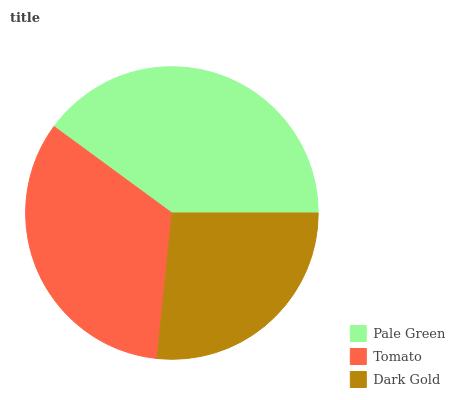Is Dark Gold the minimum?
Answer yes or no. Yes. Is Pale Green the maximum?
Answer yes or no. Yes. Is Tomato the minimum?
Answer yes or no. No. Is Tomato the maximum?
Answer yes or no. No. Is Pale Green greater than Tomato?
Answer yes or no. Yes. Is Tomato less than Pale Green?
Answer yes or no. Yes. Is Tomato greater than Pale Green?
Answer yes or no. No. Is Pale Green less than Tomato?
Answer yes or no. No. Is Tomato the high median?
Answer yes or no. Yes. Is Tomato the low median?
Answer yes or no. Yes. Is Pale Green the high median?
Answer yes or no. No. Is Dark Gold the low median?
Answer yes or no. No. 